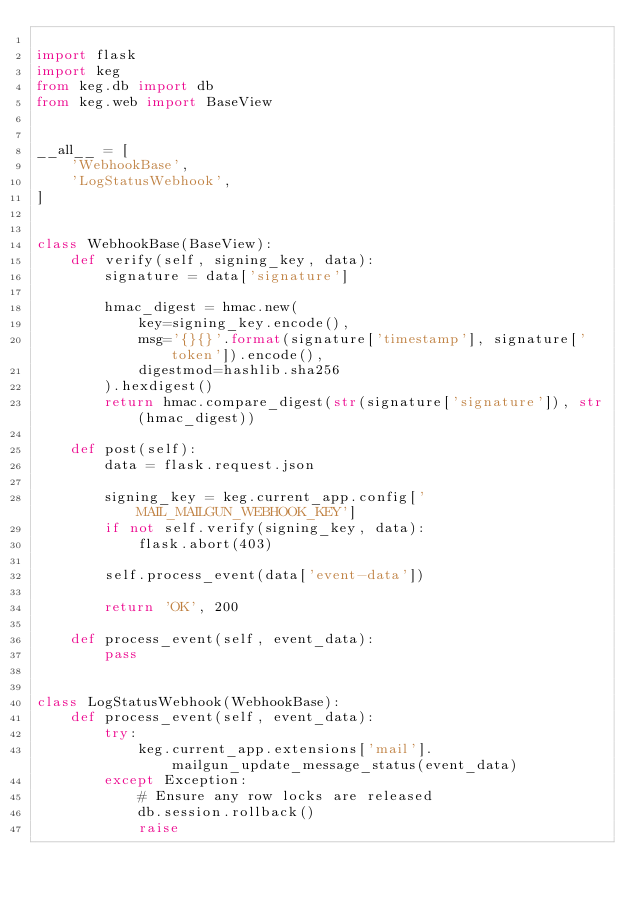<code> <loc_0><loc_0><loc_500><loc_500><_Python_>
import flask
import keg
from keg.db import db
from keg.web import BaseView


__all__ = [
    'WebhookBase',
    'LogStatusWebhook',
]


class WebhookBase(BaseView):
    def verify(self, signing_key, data):
        signature = data['signature']

        hmac_digest = hmac.new(
            key=signing_key.encode(),
            msg='{}{}'.format(signature['timestamp'], signature['token']).encode(),
            digestmod=hashlib.sha256
        ).hexdigest()
        return hmac.compare_digest(str(signature['signature']), str(hmac_digest))

    def post(self):
        data = flask.request.json

        signing_key = keg.current_app.config['MAIL_MAILGUN_WEBHOOK_KEY']
        if not self.verify(signing_key, data):
            flask.abort(403)

        self.process_event(data['event-data'])

        return 'OK', 200

    def process_event(self, event_data):
        pass


class LogStatusWebhook(WebhookBase):
    def process_event(self, event_data):
        try:
            keg.current_app.extensions['mail'].mailgun_update_message_status(event_data)
        except Exception:
            # Ensure any row locks are released
            db.session.rollback()
            raise
</code> 